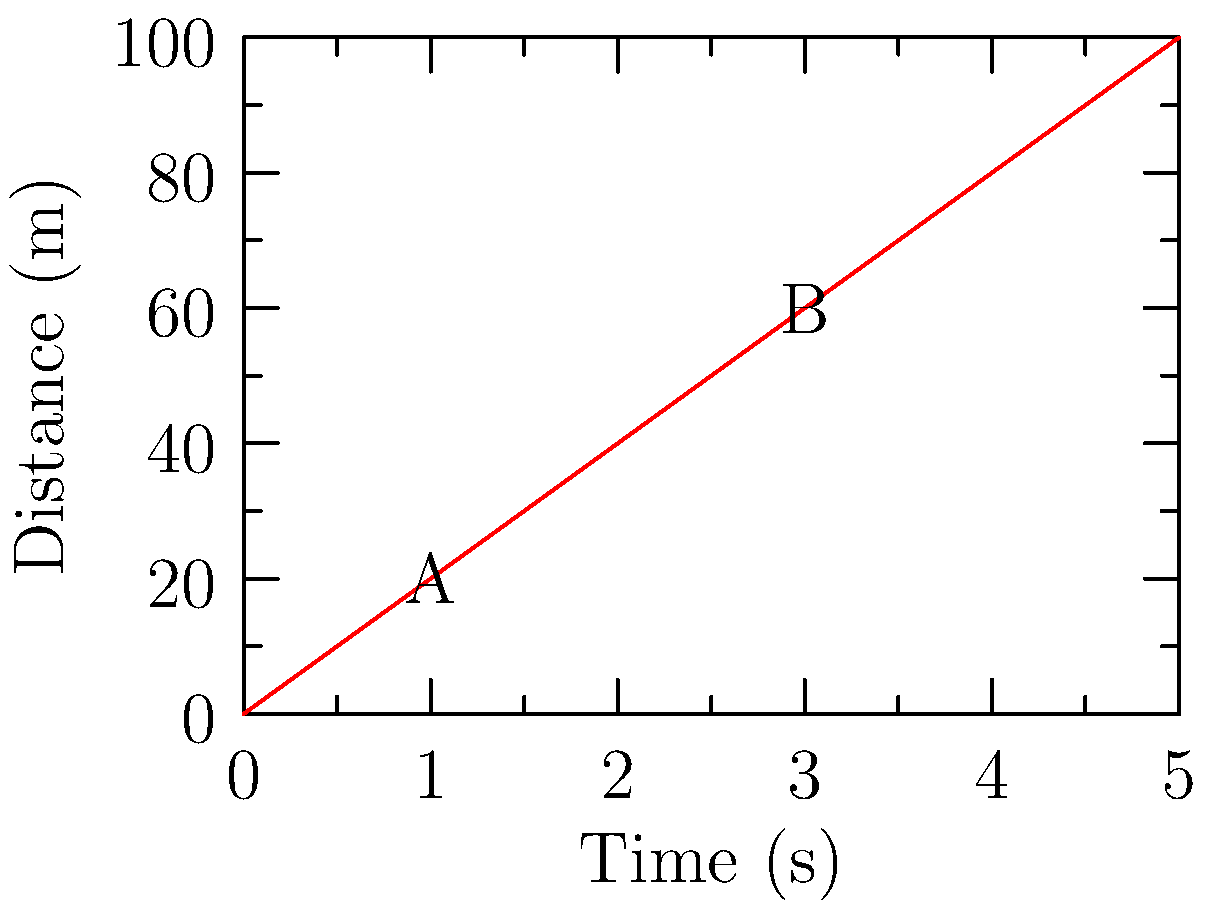A distance-time graph for a moving object is shown above. Calculate the average velocity of the object between points A and B. To calculate the average velocity, we need to determine the change in distance and the change in time between points A and B. Then we can use the formula:

$$ v = \frac{\Delta d}{\Delta t} $$

Where $v$ is velocity, $\Delta d$ is change in distance, and $\Delta t$ is change in time.

Steps:
1. Identify coordinates of points A and B:
   A: (1s, 20m)
   B: (3s, 60m)

2. Calculate change in distance ($\Delta d$):
   $\Delta d = 60\text{ m} - 20\text{ m} = 40\text{ m}$

3. Calculate change in time ($\Delta t$):
   $\Delta t = 3\text{ s} - 1\text{ s} = 2\text{ s}$

4. Apply the velocity formula:
   $$ v = \frac{\Delta d}{\Delta t} = \frac{40\text{ m}}{2\text{ s}} = 20\text{ m/s} $$

Therefore, the average velocity between points A and B is 20 m/s.
Answer: 20 m/s 